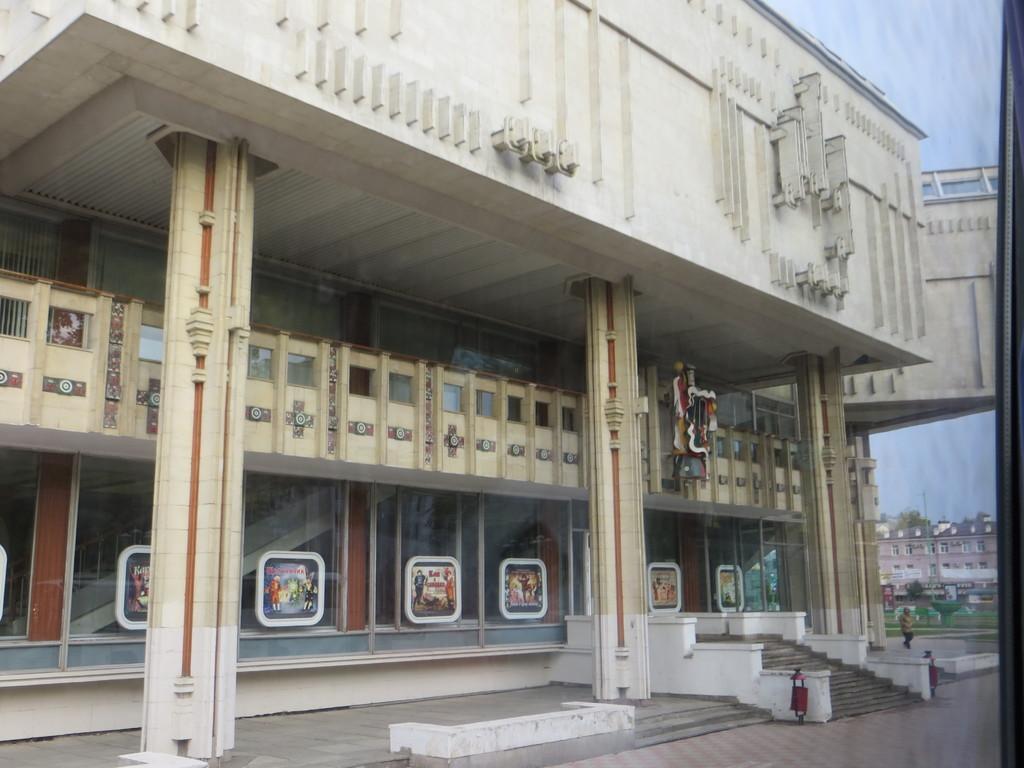How would you summarize this image in a sentence or two? In this picture we can see a building with glass windows on the right side of the building there is a person walking on the path. Behind the person there are buildings and a sky. 